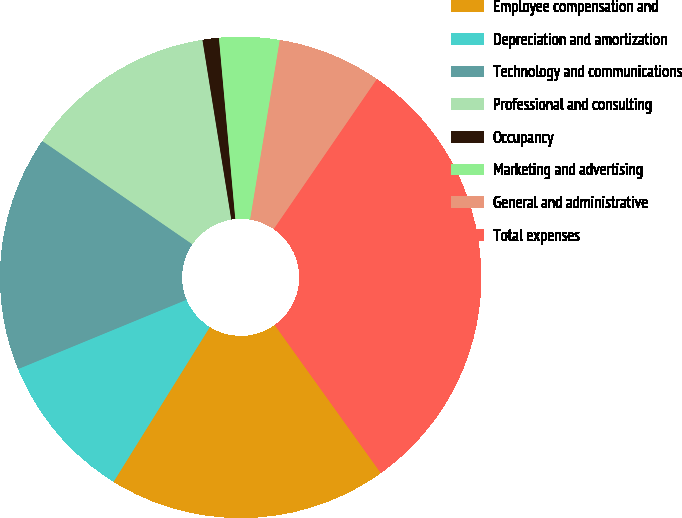<chart> <loc_0><loc_0><loc_500><loc_500><pie_chart><fcel>Employee compensation and<fcel>Depreciation and amortization<fcel>Technology and communications<fcel>Professional and consulting<fcel>Occupancy<fcel>Marketing and advertising<fcel>General and administrative<fcel>Total expenses<nl><fcel>18.75%<fcel>9.93%<fcel>15.81%<fcel>12.87%<fcel>1.1%<fcel>4.04%<fcel>6.98%<fcel>30.52%<nl></chart> 